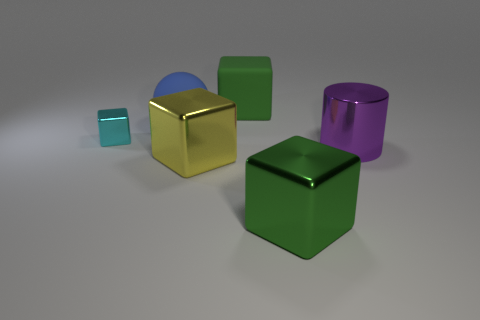Can you suggest a creative story involving the objects in the image? Certainly! In a virtual world of geometric shapes, the cubes and cylinders live harmoniously. The gold cube is the radiant leader, cherished for its reflective wisdom. The teal cube is the youngest member, admired for its energy and vibrancy. The blue semi-cylinder is the community's thinker, with half of it reflecting deep thoughts and the other half representing clear insights. The green cube is the keeper of nature, standing for growth and vitality, while the reflective purple cylinder is the mysterious sage, full of knowledge and ancient tales. 